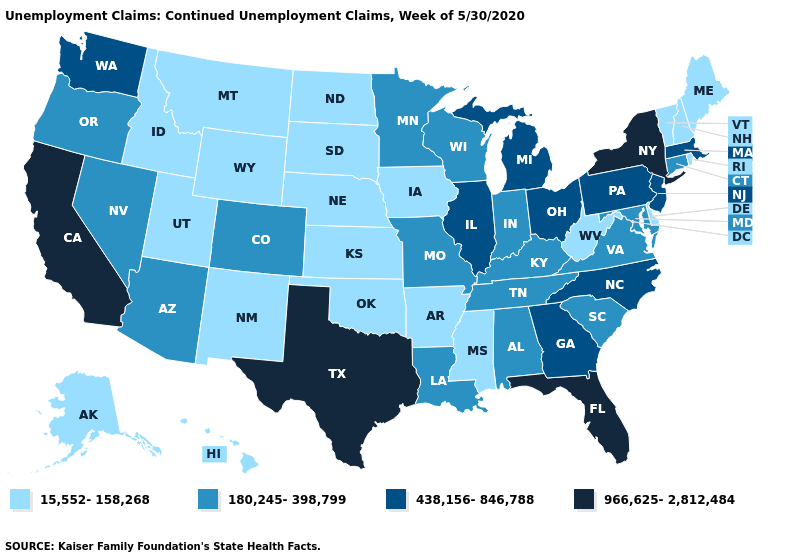Does West Virginia have a lower value than Wisconsin?
Answer briefly. Yes. Among the states that border Texas , does Louisiana have the lowest value?
Quick response, please. No. How many symbols are there in the legend?
Quick response, please. 4. Which states have the lowest value in the South?
Write a very short answer. Arkansas, Delaware, Mississippi, Oklahoma, West Virginia. Name the states that have a value in the range 180,245-398,799?
Answer briefly. Alabama, Arizona, Colorado, Connecticut, Indiana, Kentucky, Louisiana, Maryland, Minnesota, Missouri, Nevada, Oregon, South Carolina, Tennessee, Virginia, Wisconsin. What is the value of Vermont?
Short answer required. 15,552-158,268. Name the states that have a value in the range 438,156-846,788?
Keep it brief. Georgia, Illinois, Massachusetts, Michigan, New Jersey, North Carolina, Ohio, Pennsylvania, Washington. Does Idaho have the lowest value in the USA?
Quick response, please. Yes. What is the lowest value in the MidWest?
Write a very short answer. 15,552-158,268. What is the value of Kansas?
Be succinct. 15,552-158,268. Does Minnesota have a lower value than Washington?
Concise answer only. Yes. Does the map have missing data?
Concise answer only. No. What is the value of Connecticut?
Answer briefly. 180,245-398,799. Name the states that have a value in the range 180,245-398,799?
Concise answer only. Alabama, Arizona, Colorado, Connecticut, Indiana, Kentucky, Louisiana, Maryland, Minnesota, Missouri, Nevada, Oregon, South Carolina, Tennessee, Virginia, Wisconsin. Does California have a higher value than Wyoming?
Be succinct. Yes. 